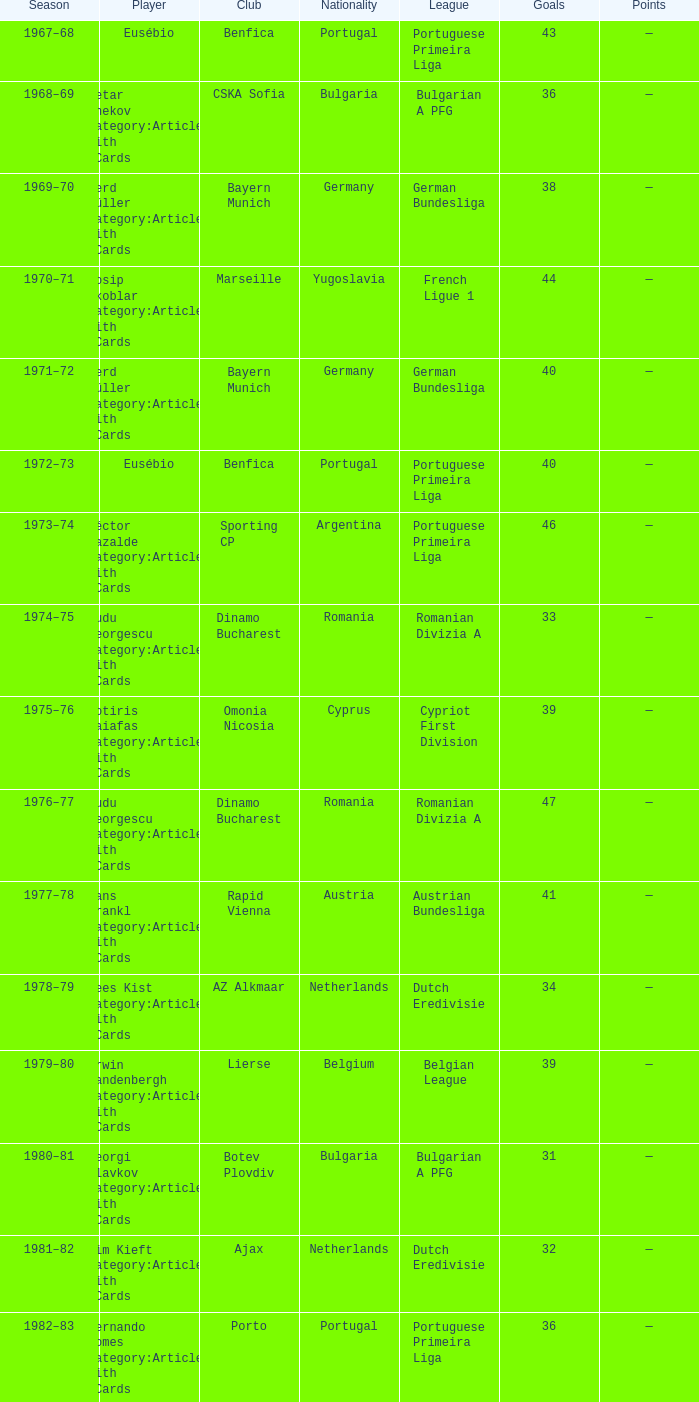Which player was in the Omonia Nicosia club? Sotiris Kaiafas Category:Articles with hCards. Could you parse the entire table? {'header': ['Season', 'Player', 'Club', 'Nationality', 'League', 'Goals', 'Points'], 'rows': [['1967–68', 'Eusébio', 'Benfica', 'Portugal', 'Portuguese Primeira Liga', '43', '—'], ['1968–69', 'Petar Zhekov Category:Articles with hCards', 'CSKA Sofia', 'Bulgaria', 'Bulgarian A PFG', '36', '—'], ['1969–70', 'Gerd Müller Category:Articles with hCards', 'Bayern Munich', 'Germany', 'German Bundesliga', '38', '—'], ['1970–71', 'Josip Skoblar Category:Articles with hCards', 'Marseille', 'Yugoslavia', 'French Ligue 1', '44', '—'], ['1971–72', 'Gerd Müller Category:Articles with hCards', 'Bayern Munich', 'Germany', 'German Bundesliga', '40', '—'], ['1972–73', 'Eusébio', 'Benfica', 'Portugal', 'Portuguese Primeira Liga', '40', '—'], ['1973–74', 'Héctor Yazalde Category:Articles with hCards', 'Sporting CP', 'Argentina', 'Portuguese Primeira Liga', '46', '—'], ['1974–75', 'Dudu Georgescu Category:Articles with hCards', 'Dinamo Bucharest', 'Romania', 'Romanian Divizia A', '33', '—'], ['1975–76', 'Sotiris Kaiafas Category:Articles with hCards', 'Omonia Nicosia', 'Cyprus', 'Cypriot First Division', '39', '—'], ['1976–77', 'Dudu Georgescu Category:Articles with hCards', 'Dinamo Bucharest', 'Romania', 'Romanian Divizia A', '47', '—'], ['1977–78', 'Hans Krankl Category:Articles with hCards', 'Rapid Vienna', 'Austria', 'Austrian Bundesliga', '41', '—'], ['1978–79', 'Kees Kist Category:Articles with hCards', 'AZ Alkmaar', 'Netherlands', 'Dutch Eredivisie', '34', '—'], ['1979–80', 'Erwin Vandenbergh Category:Articles with hCards', 'Lierse', 'Belgium', 'Belgian League', '39', '—'], ['1980–81', 'Georgi Slavkov Category:Articles with hCards', 'Botev Plovdiv', 'Bulgaria', 'Bulgarian A PFG', '31', '—'], ['1981–82', 'Wim Kieft Category:Articles with hCards', 'Ajax', 'Netherlands', 'Dutch Eredivisie', '32', '—'], ['1982–83', 'Fernando Gomes Category:Articles with hCards', 'Porto', 'Portugal', 'Portuguese Primeira Liga', '36', '—'], ['1983–84', 'Ian Rush Category:Articles with hCards', 'Liverpool', 'Wales', 'English First Division', '32', '—'], ['1984–85', 'Fernando Gomes Category:Articles with hCards', 'Porto', 'Portugal', 'Portuguese Primeira Liga', '39', '—'], ['1985–86', 'Marco van Basten Category:Articles with hCards', 'Ajax', 'Netherlands', 'Dutch Eredivisie', '37', '—'], ['1986–87', 'Rodion Cămătaru', 'Dinamo Bucharest', 'Romania', 'Romanian Divizia A', '44', '—'], ['1986–87', 'Toni Polster', 'Austria Wien', 'Austria', 'Austrian Bundesliga', '39', '—'], ['1987–88', 'Tanju Çolak Category:Articles with hCards', 'Galatasaray', 'Turkey', 'Süper Lig', '39', '—'], ['1988–89', 'Dorin Mateuţ Category:Articles with hCards', 'Dinamo Bucharest', 'Romania', 'Romanian Divizia A', '43', '—'], ['1989–90', 'Hugo Sánchez Category:Articles with hCards', 'Real Madrid', 'Mexico', 'Spanish La Liga', '38', '—'], ['1989–90', 'Hristo Stoichkov Category:Articles with hCards', 'CSKA Sofia', 'Bulgaria', 'Bulgarian A PFG', '38', '—'], ['1990–91', 'Darko Pančev Category:Articles with hCards', 'Red Star', 'Yugoslavia', 'Yugoslav First League', '34', '—'], ['1991–92', 'Ally McCoist Category:Articles with hCards', 'Rangers', 'Scotland', 'Scottish Premier Division', '34', '—'], ['1992–93', 'Ally McCoist Category:Articles with hCards', 'Rangers', 'Scotland', 'Scottish Premier Division', '34', '—'], ['1993–94', 'David Taylor Category:Articles with hCards', 'Porthmadog', 'Wales', 'League of Wales', '43', '—'], ['1994–95', 'Arsen Avetisyan Category:Articles with hCards', 'Homenetmen', 'Armenia', 'Armenian Premier League', '39', '—'], ['1995–96', 'Zviad Endeladze Category:Articles with hCards', 'Margveti', 'Georgia', 'Georgian Umaglesi Liga', '40', '—'], ['1996–97', 'Ronaldo', 'Barcelona', 'Brazil', 'Spanish La Liga', '34', '68'], ['1997–98', 'Nikos Machlas Category:Articles with hCards', 'Vitesse', 'Greece', 'Dutch Eredivisie', '34', '68'], ['1998–99', 'Mário Jardel Category:Articles with hCards', 'Porto', 'Brazil', 'Portuguese Primeira Liga', '36', '72'], ['1999–2000', 'Kevin Phillips Category:Articles with hCards', 'Sunderland', 'England', 'English Premier League', '30', '60'], ['2000–01', 'Henrik Larsson Category:Articles with hCards', 'Celtic', 'Sweden', 'Scottish Premier League', '35', '52.5'], ['2001–02', 'Mário Jardel Category:Articles with hCards', 'Sporting CP', 'Brazil', 'Portuguese Primeira Liga', '42', '84'], ['2002–03', 'Roy Makaay Category:Articles with hCards', 'Deportivo La Coruña', 'Netherlands', 'Spanish La Liga', '29', '58'], ['2003–04', 'Thierry Henry Category:Articles with hCards', 'Arsenal', 'France', 'English Premier League', '30', '60'], ['2004–05', 'Thierry Henry Category:Articles with hCards', 'Arsenal', 'France', 'English Premier League', '25', '50'], ['2004–05', 'Diego Forlán Category:Articles with hCards', 'Villarreal', 'Uruguay', 'Spanish La Liga', '25', '50'], ['2005–06', 'Luca Toni Category:Articles with hCards', 'Fiorentina', 'Italy', 'Italian Serie A', '31', '62'], ['2006–07', 'Francesco Totti Category:Articles with hCards', 'Roma', 'Italy', 'Italian Serie A', '26', '52'], ['2007–08', 'Cristiano Ronaldo Category:Articles with hCards', 'Manchester United', 'Portugal', 'English Premier League', '31', '62'], ['2008–09', 'Diego Forlán Category:Articles with hCards', 'Atlético Madrid', 'Uruguay', 'Spanish La Liga', '32', '64'], ['2009–10', 'Lionel Messi Category:Articles with hCards', 'Barcelona', 'Argentina', 'Spanish La Liga', '34', '68'], ['2010–11', 'Cristiano Ronaldo Category:Articles with hCards', 'Real Madrid', 'Portugal', 'Spanish La Liga', '40', '80'], ['2011–12', 'Lionel Messi Category:Articles with hCards', 'Barcelona', 'Argentina', 'Spanish La Liga', '50', '100'], ['2012–13', 'Lionel Messi Category:Articles with hCards', 'Barcelona', 'Argentina', 'Spanish La Liga', '46', '92']]} 